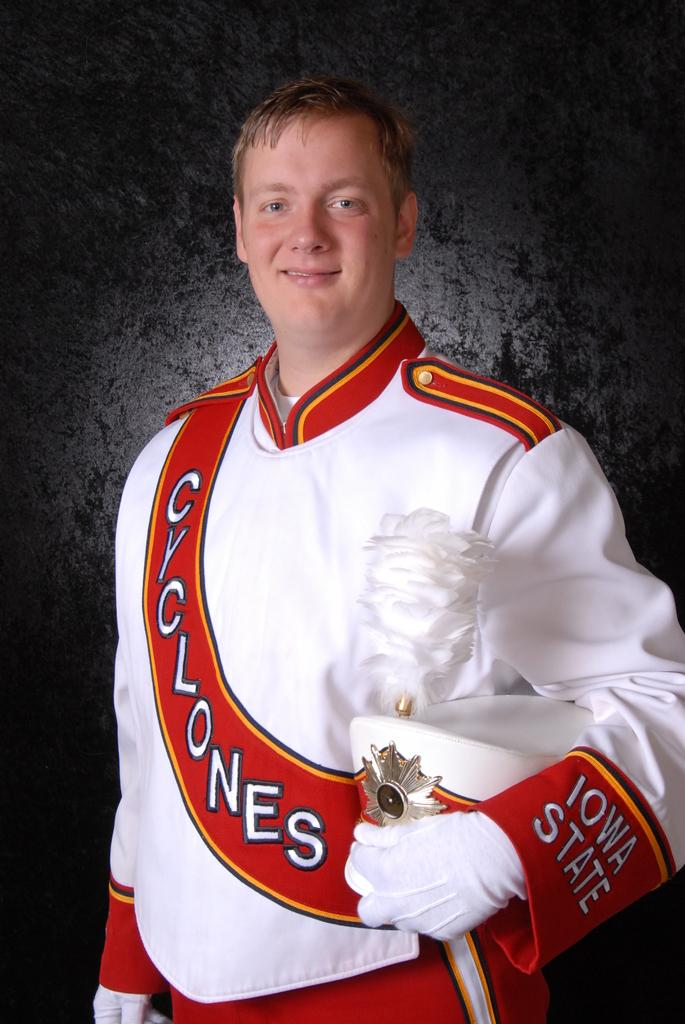<image>
Write a terse but informative summary of the picture. A man in an Iowa State Cyclones Marching band uniform. 